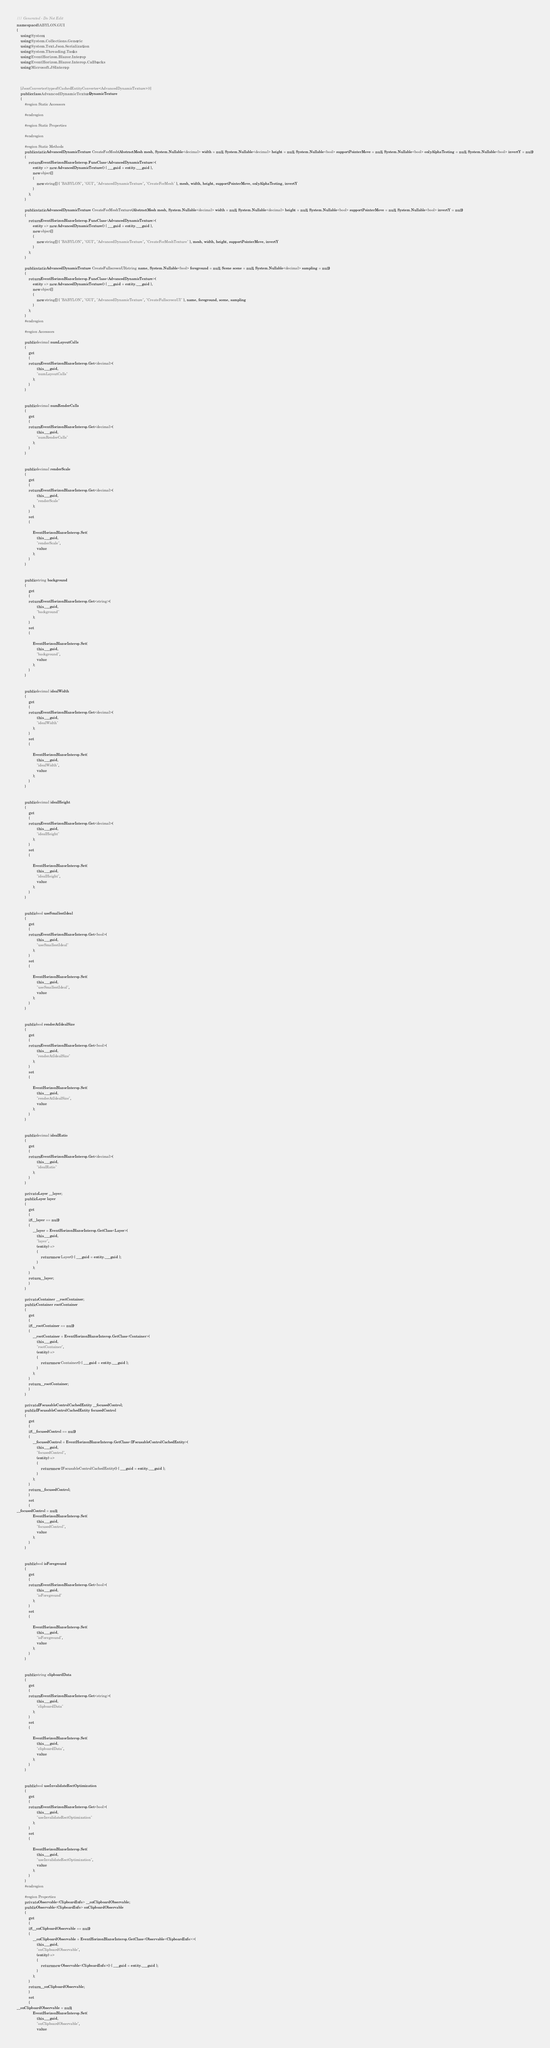<code> <loc_0><loc_0><loc_500><loc_500><_C#_>/// Generated - Do Not Edit
namespace BABYLON.GUI
{
    using System;
    using System.Collections.Generic;
    using System.Text.Json.Serialization;
    using System.Threading.Tasks;
    using EventHorizon.Blazor.Interop;
    using EventHorizon.Blazor.Interop.Callbacks;
    using Microsoft.JSInterop;

    
    
    [JsonConverter(typeof(CachedEntityConverter<AdvancedDynamicTexture>))]
    public class AdvancedDynamicTexture : DynamicTexture
    {
        #region Static Accessors

        #endregion

        #region Static Properties

        #endregion

        #region Static Methods
        public static AdvancedDynamicTexture CreateForMesh(AbstractMesh mesh, System.Nullable<decimal> width = null, System.Nullable<decimal> height = null, System.Nullable<bool> supportPointerMove = null, System.Nullable<bool> onlyAlphaTesting = null, System.Nullable<bool> invertY = null)
        {
            return EventHorizonBlazorInterop.FuncClass<AdvancedDynamicTexture>(
                entity => new AdvancedDynamicTexture() { ___guid = entity.___guid },
                new object[]
                {
                    new string[] { "BABYLON", "GUI", "AdvancedDynamicTexture", "CreateForMesh" }, mesh, width, height, supportPointerMove, onlyAlphaTesting, invertY
                }
            );
        }

        public static AdvancedDynamicTexture CreateForMeshTexture(AbstractMesh mesh, System.Nullable<decimal> width = null, System.Nullable<decimal> height = null, System.Nullable<bool> supportPointerMove = null, System.Nullable<bool> invertY = null)
        {
            return EventHorizonBlazorInterop.FuncClass<AdvancedDynamicTexture>(
                entity => new AdvancedDynamicTexture() { ___guid = entity.___guid },
                new object[]
                {
                    new string[] { "BABYLON", "GUI", "AdvancedDynamicTexture", "CreateForMeshTexture" }, mesh, width, height, supportPointerMove, invertY
                }
            );
        }

        public static AdvancedDynamicTexture CreateFullscreenUI(string name, System.Nullable<bool> foreground = null, Scene scene = null, System.Nullable<decimal> sampling = null)
        {
            return EventHorizonBlazorInterop.FuncClass<AdvancedDynamicTexture>(
                entity => new AdvancedDynamicTexture() { ___guid = entity.___guid },
                new object[]
                {
                    new string[] { "BABYLON", "GUI", "AdvancedDynamicTexture", "CreateFullscreenUI" }, name, foreground, scene, sampling
                }
            );
        }
        #endregion

        #region Accessors
        
        public decimal numLayoutCalls
        {
            get
            {
            return EventHorizonBlazorInterop.Get<decimal>(
                    this.___guid,
                    "numLayoutCalls"
                );
            }
        }

        
        public decimal numRenderCalls
        {
            get
            {
            return EventHorizonBlazorInterop.Get<decimal>(
                    this.___guid,
                    "numRenderCalls"
                );
            }
        }

        
        public decimal renderScale
        {
            get
            {
            return EventHorizonBlazorInterop.Get<decimal>(
                    this.___guid,
                    "renderScale"
                );
            }
            set
            {

                EventHorizonBlazorInterop.Set(
                    this.___guid,
                    "renderScale",
                    value
                );
            }
        }

        
        public string background
        {
            get
            {
            return EventHorizonBlazorInterop.Get<string>(
                    this.___guid,
                    "background"
                );
            }
            set
            {

                EventHorizonBlazorInterop.Set(
                    this.___guid,
                    "background",
                    value
                );
            }
        }

        
        public decimal idealWidth
        {
            get
            {
            return EventHorizonBlazorInterop.Get<decimal>(
                    this.___guid,
                    "idealWidth"
                );
            }
            set
            {

                EventHorizonBlazorInterop.Set(
                    this.___guid,
                    "idealWidth",
                    value
                );
            }
        }

        
        public decimal idealHeight
        {
            get
            {
            return EventHorizonBlazorInterop.Get<decimal>(
                    this.___guid,
                    "idealHeight"
                );
            }
            set
            {

                EventHorizonBlazorInterop.Set(
                    this.___guid,
                    "idealHeight",
                    value
                );
            }
        }

        
        public bool useSmallestIdeal
        {
            get
            {
            return EventHorizonBlazorInterop.Get<bool>(
                    this.___guid,
                    "useSmallestIdeal"
                );
            }
            set
            {

                EventHorizonBlazorInterop.Set(
                    this.___guid,
                    "useSmallestIdeal",
                    value
                );
            }
        }

        
        public bool renderAtIdealSize
        {
            get
            {
            return EventHorizonBlazorInterop.Get<bool>(
                    this.___guid,
                    "renderAtIdealSize"
                );
            }
            set
            {

                EventHorizonBlazorInterop.Set(
                    this.___guid,
                    "renderAtIdealSize",
                    value
                );
            }
        }

        
        public decimal idealRatio
        {
            get
            {
            return EventHorizonBlazorInterop.Get<decimal>(
                    this.___guid,
                    "idealRatio"
                );
            }
        }

        private Layer __layer;
        public Layer layer
        {
            get
            {
            if(__layer == null)
            {
                __layer = EventHorizonBlazorInterop.GetClass<Layer>(
                    this.___guid,
                    "layer",
                    (entity) =>
                    {
                        return new Layer() { ___guid = entity.___guid };
                    }
                );
            }
            return __layer;
            }
        }

        private Container __rootContainer;
        public Container rootContainer
        {
            get
            {
            if(__rootContainer == null)
            {
                __rootContainer = EventHorizonBlazorInterop.GetClass<Container>(
                    this.___guid,
                    "rootContainer",
                    (entity) =>
                    {
                        return new Container() { ___guid = entity.___guid };
                    }
                );
            }
            return __rootContainer;
            }
        }

        private IFocusableControlCachedEntity __focusedControl;
        public IFocusableControlCachedEntity focusedControl
        {
            get
            {
            if(__focusedControl == null)
            {
                __focusedControl = EventHorizonBlazorInterop.GetClass<IFocusableControlCachedEntity>(
                    this.___guid,
                    "focusedControl",
                    (entity) =>
                    {
                        return new IFocusableControlCachedEntity() { ___guid = entity.___guid };
                    }
                );
            }
            return __focusedControl;
            }
            set
            {
__focusedControl = null;
                EventHorizonBlazorInterop.Set(
                    this.___guid,
                    "focusedControl",
                    value
                );
            }
        }

        
        public bool isForeground
        {
            get
            {
            return EventHorizonBlazorInterop.Get<bool>(
                    this.___guid,
                    "isForeground"
                );
            }
            set
            {

                EventHorizonBlazorInterop.Set(
                    this.___guid,
                    "isForeground",
                    value
                );
            }
        }

        
        public string clipboardData
        {
            get
            {
            return EventHorizonBlazorInterop.Get<string>(
                    this.___guid,
                    "clipboardData"
                );
            }
            set
            {

                EventHorizonBlazorInterop.Set(
                    this.___guid,
                    "clipboardData",
                    value
                );
            }
        }

        
        public bool useInvalidateRectOptimization
        {
            get
            {
            return EventHorizonBlazorInterop.Get<bool>(
                    this.___guid,
                    "useInvalidateRectOptimization"
                );
            }
            set
            {

                EventHorizonBlazorInterop.Set(
                    this.___guid,
                    "useInvalidateRectOptimization",
                    value
                );
            }
        }
        #endregion

        #region Properties
        private Observable<ClipboardInfo> __onClipboardObservable;
        public Observable<ClipboardInfo> onClipboardObservable
        {
            get
            {
            if(__onClipboardObservable == null)
            {
                __onClipboardObservable = EventHorizonBlazorInterop.GetClass<Observable<ClipboardInfo>>(
                    this.___guid,
                    "onClipboardObservable",
                    (entity) =>
                    {
                        return new Observable<ClipboardInfo>() { ___guid = entity.___guid };
                    }
                );
            }
            return __onClipboardObservable;
            }
            set
            {
__onClipboardObservable = null;
                EventHorizonBlazorInterop.Set(
                    this.___guid,
                    "onClipboardObservable",
                    value</code> 